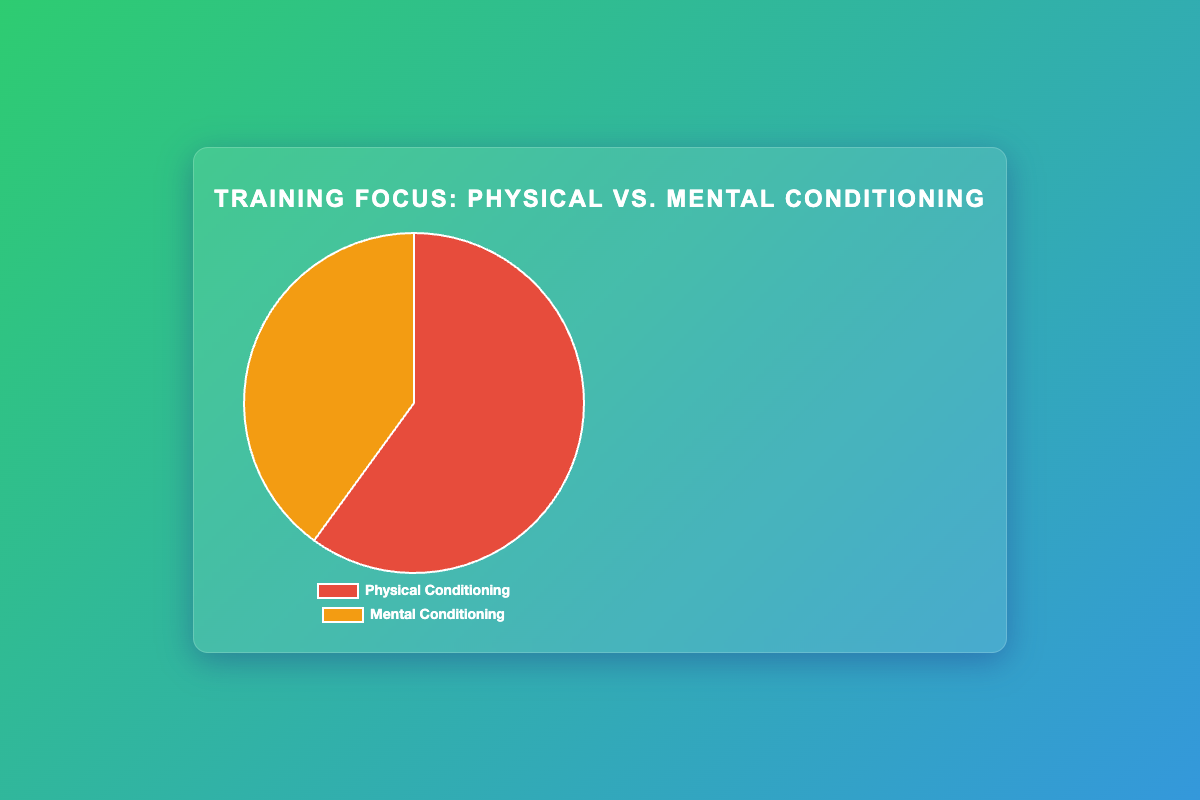What percentage of the training focus is on physical conditioning versus mental conditioning? The pie chart shows two segments labeled 'Physical Conditioning' and 'Mental Conditioning.' By inspecting the chart, 'Physical Conditioning' constitutes 60% of the training focus, and 'Mental Conditioning' makes up 40%.
Answer: 60% for Physical Conditioning, 40% for Mental Conditioning Which type of conditioning has a higher focus? The visualization shows that the 'Physical Conditioning' segment is larger than the 'Mental Conditioning' segment, indicating that physical conditioning is the primary focus.
Answer: Physical Conditioning How much greater is the focus on physical conditioning compared to mental conditioning? The pie chart shows physical conditioning at 60% and mental conditioning at 40%. The difference between them is 60% - 40% = 20%.
Answer: 20% If the total percentage is 100%, how much focus is left for other types of training aside from physical and mental conditioning? The pie chart is designed so that the sum of all shown segments equals 100%. Since 60% + 40% = 100%, there is no leftover percentage for other types of training.
Answer: 0% Which segment in the pie chart is represented by a red color? The chart segments for 'Physical Conditioning' and 'Mental Conditioning' are colored differently. The 'Physical Conditioning' segment is red.
Answer: Physical Conditioning Is the percentage dedicated to mental conditioning more than half of the total training focus? Mental conditioning accounts for 40% of the total training focus, which is less than half of 100%.
Answer: No Comparing the visualization techniques and goal setting, which one constitutes a larger share of mental conditioning? Among the entities within 'Mental Conditioning,' 'Mindfulness Meditation' at 15% is the largest. Both 'Visualization Techniques' and 'Goal Setting' are at 10% each, making them equal.
Answer: They are equal What is the average percentage of focus on each physical conditioning activity? Physical Conditioning consists of three activities making up 60%. The average is calculated as (30% + 20% + 10%) / 3 = 60% / 3 = 20%.
Answer: 20% How does the focus on cardio workouts compare to the focus on all types of mental conditioning combined? 'Cardio Workouts' make up 10% within physical conditioning. The total mental conditioning is 40%. Thus, 'Cardio Workouts' at 10% are much smaller compared to the total focus of 40% on all mental conditioning activities.
Answer: Cardio Workouts is smaller 